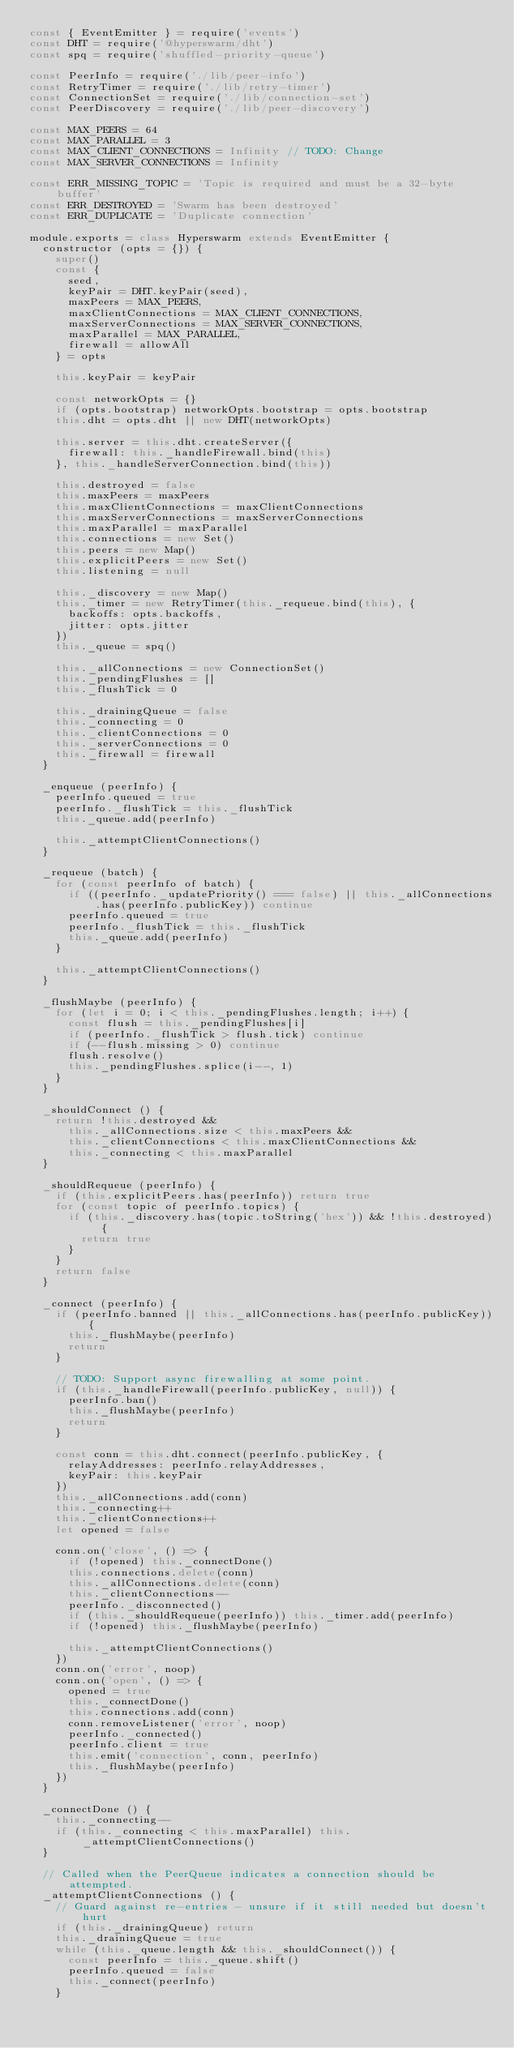Convert code to text. <code><loc_0><loc_0><loc_500><loc_500><_JavaScript_>const { EventEmitter } = require('events')
const DHT = require('@hyperswarm/dht')
const spq = require('shuffled-priority-queue')

const PeerInfo = require('./lib/peer-info')
const RetryTimer = require('./lib/retry-timer')
const ConnectionSet = require('./lib/connection-set')
const PeerDiscovery = require('./lib/peer-discovery')

const MAX_PEERS = 64
const MAX_PARALLEL = 3
const MAX_CLIENT_CONNECTIONS = Infinity // TODO: Change
const MAX_SERVER_CONNECTIONS = Infinity

const ERR_MISSING_TOPIC = 'Topic is required and must be a 32-byte buffer'
const ERR_DESTROYED = 'Swarm has been destroyed'
const ERR_DUPLICATE = 'Duplicate connection'

module.exports = class Hyperswarm extends EventEmitter {
  constructor (opts = {}) {
    super()
    const {
      seed,
      keyPair = DHT.keyPair(seed),
      maxPeers = MAX_PEERS,
      maxClientConnections = MAX_CLIENT_CONNECTIONS,
      maxServerConnections = MAX_SERVER_CONNECTIONS,
      maxParallel = MAX_PARALLEL,
      firewall = allowAll
    } = opts

    this.keyPair = keyPair

    const networkOpts = {}
    if (opts.bootstrap) networkOpts.bootstrap = opts.bootstrap
    this.dht = opts.dht || new DHT(networkOpts)

    this.server = this.dht.createServer({
      firewall: this._handleFirewall.bind(this)
    }, this._handleServerConnection.bind(this))

    this.destroyed = false
    this.maxPeers = maxPeers
    this.maxClientConnections = maxClientConnections
    this.maxServerConnections = maxServerConnections
    this.maxParallel = maxParallel
    this.connections = new Set()
    this.peers = new Map()
    this.explicitPeers = new Set()
    this.listening = null

    this._discovery = new Map()
    this._timer = new RetryTimer(this._requeue.bind(this), {
      backoffs: opts.backoffs,
      jitter: opts.jitter
    })
    this._queue = spq()

    this._allConnections = new ConnectionSet()
    this._pendingFlushes = []
    this._flushTick = 0

    this._drainingQueue = false
    this._connecting = 0
    this._clientConnections = 0
    this._serverConnections = 0
    this._firewall = firewall
  }

  _enqueue (peerInfo) {
    peerInfo.queued = true
    peerInfo._flushTick = this._flushTick
    this._queue.add(peerInfo)

    this._attemptClientConnections()
  }

  _requeue (batch) {
    for (const peerInfo of batch) {
      if ((peerInfo._updatePriority() === false) || this._allConnections.has(peerInfo.publicKey)) continue
      peerInfo.queued = true
      peerInfo._flushTick = this._flushTick
      this._queue.add(peerInfo)
    }

    this._attemptClientConnections()
  }

  _flushMaybe (peerInfo) {
    for (let i = 0; i < this._pendingFlushes.length; i++) {
      const flush = this._pendingFlushes[i]
      if (peerInfo._flushTick > flush.tick) continue
      if (--flush.missing > 0) continue
      flush.resolve()
      this._pendingFlushes.splice(i--, 1)
    }
  }

  _shouldConnect () {
    return !this.destroyed &&
      this._allConnections.size < this.maxPeers &&
      this._clientConnections < this.maxClientConnections &&
      this._connecting < this.maxParallel
  }

  _shouldRequeue (peerInfo) {
    if (this.explicitPeers.has(peerInfo)) return true
    for (const topic of peerInfo.topics) {
      if (this._discovery.has(topic.toString('hex')) && !this.destroyed) {
        return true
      }
    }
    return false
  }

  _connect (peerInfo) {
    if (peerInfo.banned || this._allConnections.has(peerInfo.publicKey)) {
      this._flushMaybe(peerInfo)
      return
    }

    // TODO: Support async firewalling at some point.
    if (this._handleFirewall(peerInfo.publicKey, null)) {
      peerInfo.ban()
      this._flushMaybe(peerInfo)
      return
    }

    const conn = this.dht.connect(peerInfo.publicKey, {
      relayAddresses: peerInfo.relayAddresses,
      keyPair: this.keyPair
    })
    this._allConnections.add(conn)
    this._connecting++
    this._clientConnections++
    let opened = false

    conn.on('close', () => {
      if (!opened) this._connectDone()
      this.connections.delete(conn)
      this._allConnections.delete(conn)
      this._clientConnections--
      peerInfo._disconnected()
      if (this._shouldRequeue(peerInfo)) this._timer.add(peerInfo)
      if (!opened) this._flushMaybe(peerInfo)

      this._attemptClientConnections()
    })
    conn.on('error', noop)
    conn.on('open', () => {
      opened = true
      this._connectDone()
      this.connections.add(conn)
      conn.removeListener('error', noop)
      peerInfo._connected()
      peerInfo.client = true
      this.emit('connection', conn, peerInfo)
      this._flushMaybe(peerInfo)
    })
  }

  _connectDone () {
    this._connecting--
    if (this._connecting < this.maxParallel) this._attemptClientConnections()
  }

  // Called when the PeerQueue indicates a connection should be attempted.
  _attemptClientConnections () {
    // Guard against re-entries - unsure if it still needed but doesn't hurt
    if (this._drainingQueue) return
    this._drainingQueue = true
    while (this._queue.length && this._shouldConnect()) {
      const peerInfo = this._queue.shift()
      peerInfo.queued = false
      this._connect(peerInfo)
    }</code> 